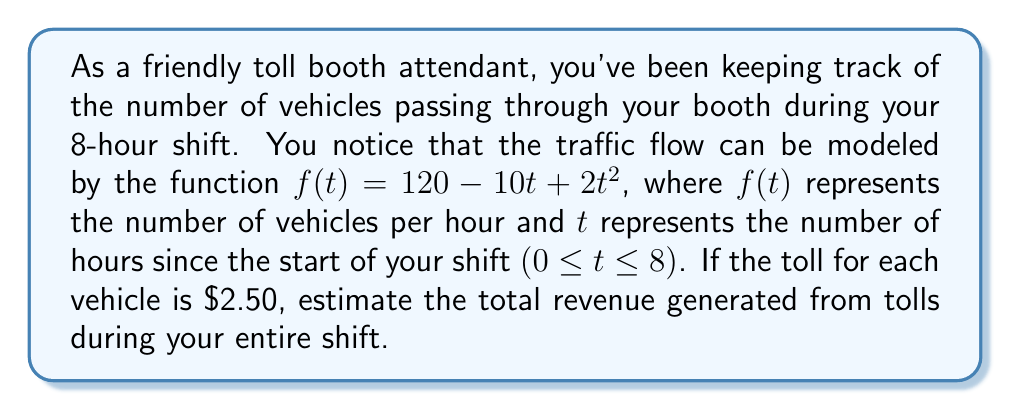Can you answer this question? To solve this problem, we need to follow these steps:

1) First, we need to find the total number of vehicles that passed through the toll booth during the 8-hour shift. This can be done by integrating the function $f(t)$ from 0 to 8.

   $$\int_0^8 f(t) dt = \int_0^8 (120 - 10t + 2t^2) dt$$

2) Let's solve this integral:

   $$\int_0^8 (120 - 10t + 2t^2) dt = [120t - 5t^2 + \frac{2}{3}t^3]_0^8$$

3) Evaluating at the limits:

   $$= (120(8) - 5(8^2) + \frac{2}{3}(8^3)) - (120(0) - 5(0^2) + \frac{2}{3}(0^3))$$
   $$= (960 - 320 + 341.33) - 0 = 981.33$$

4) So, approximately 981 vehicles passed through the toll booth during the 8-hour shift.

5) Now, we can calculate the total revenue by multiplying the number of vehicles by the toll fee:

   $$981.33 \times \$2.50 = \$2,453.33$$

Therefore, the estimated total revenue generated from tolls during your 8-hour shift is $\$2,453.33$.
Answer: $\$2,453.33$ 